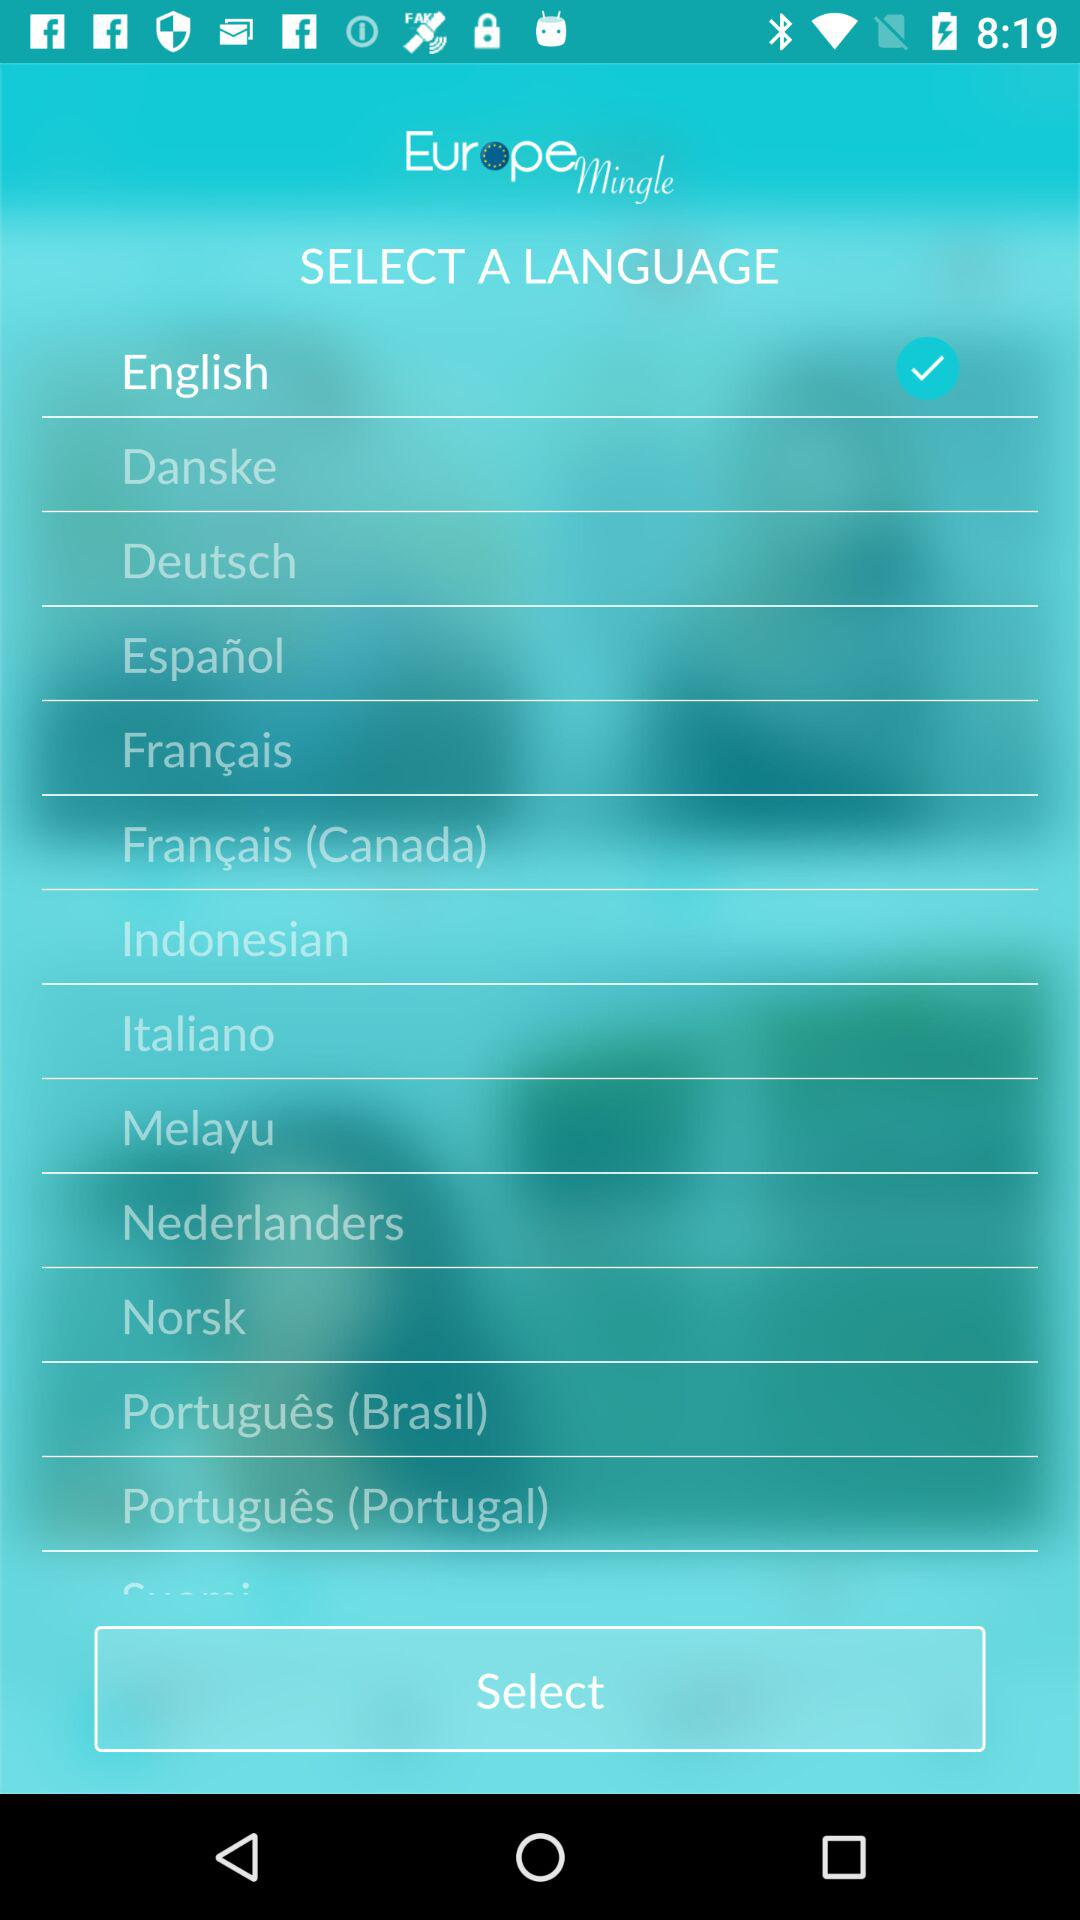Is the user male or female?
When the provided information is insufficient, respond with <no answer>. <no answer> 